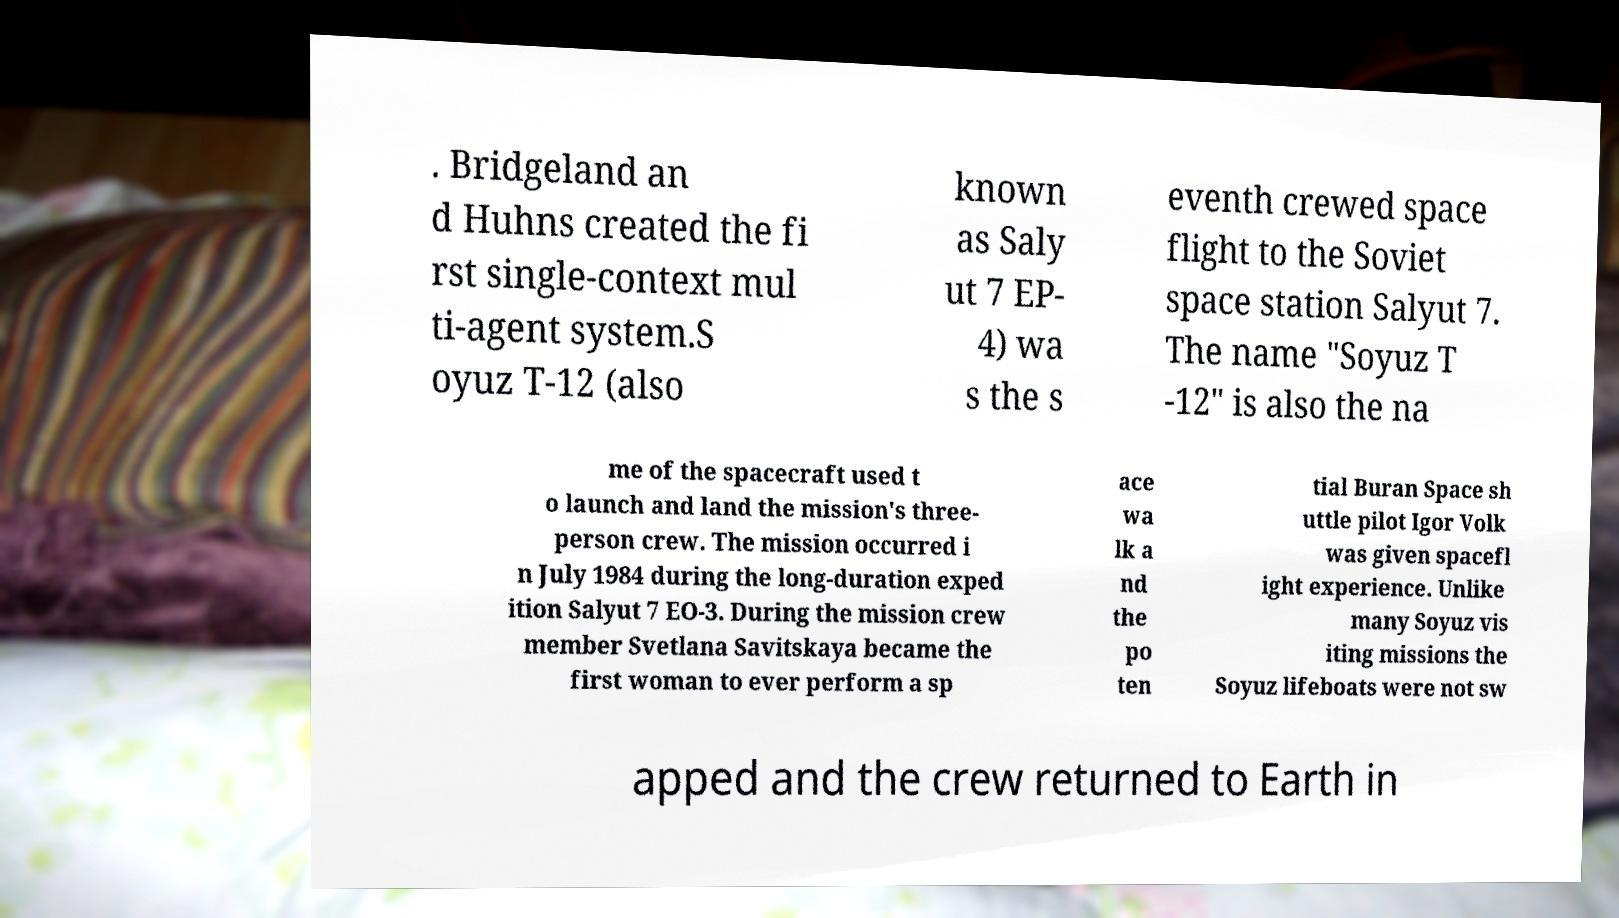Could you extract and type out the text from this image? . Bridgeland an d Huhns created the fi rst single-context mul ti-agent system.S oyuz T-12 (also known as Saly ut 7 EP- 4) wa s the s eventh crewed space flight to the Soviet space station Salyut 7. The name "Soyuz T -12" is also the na me of the spacecraft used t o launch and land the mission's three- person crew. The mission occurred i n July 1984 during the long-duration exped ition Salyut 7 EO-3. During the mission crew member Svetlana Savitskaya became the first woman to ever perform a sp ace wa lk a nd the po ten tial Buran Space sh uttle pilot Igor Volk was given spacefl ight experience. Unlike many Soyuz vis iting missions the Soyuz lifeboats were not sw apped and the crew returned to Earth in 